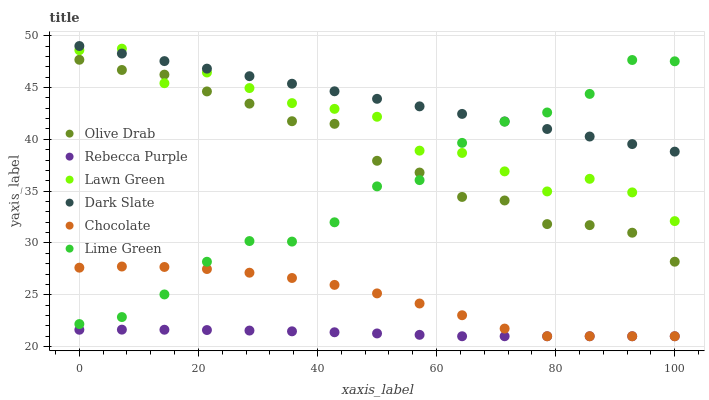Does Rebecca Purple have the minimum area under the curve?
Answer yes or no. Yes. Does Dark Slate have the maximum area under the curve?
Answer yes or no. Yes. Does Chocolate have the minimum area under the curve?
Answer yes or no. No. Does Chocolate have the maximum area under the curve?
Answer yes or no. No. Is Dark Slate the smoothest?
Answer yes or no. Yes. Is Lawn Green the roughest?
Answer yes or no. Yes. Is Chocolate the smoothest?
Answer yes or no. No. Is Chocolate the roughest?
Answer yes or no. No. Does Chocolate have the lowest value?
Answer yes or no. Yes. Does Dark Slate have the lowest value?
Answer yes or no. No. Does Dark Slate have the highest value?
Answer yes or no. Yes. Does Chocolate have the highest value?
Answer yes or no. No. Is Rebecca Purple less than Lawn Green?
Answer yes or no. Yes. Is Dark Slate greater than Olive Drab?
Answer yes or no. Yes. Does Chocolate intersect Rebecca Purple?
Answer yes or no. Yes. Is Chocolate less than Rebecca Purple?
Answer yes or no. No. Is Chocolate greater than Rebecca Purple?
Answer yes or no. No. Does Rebecca Purple intersect Lawn Green?
Answer yes or no. No. 